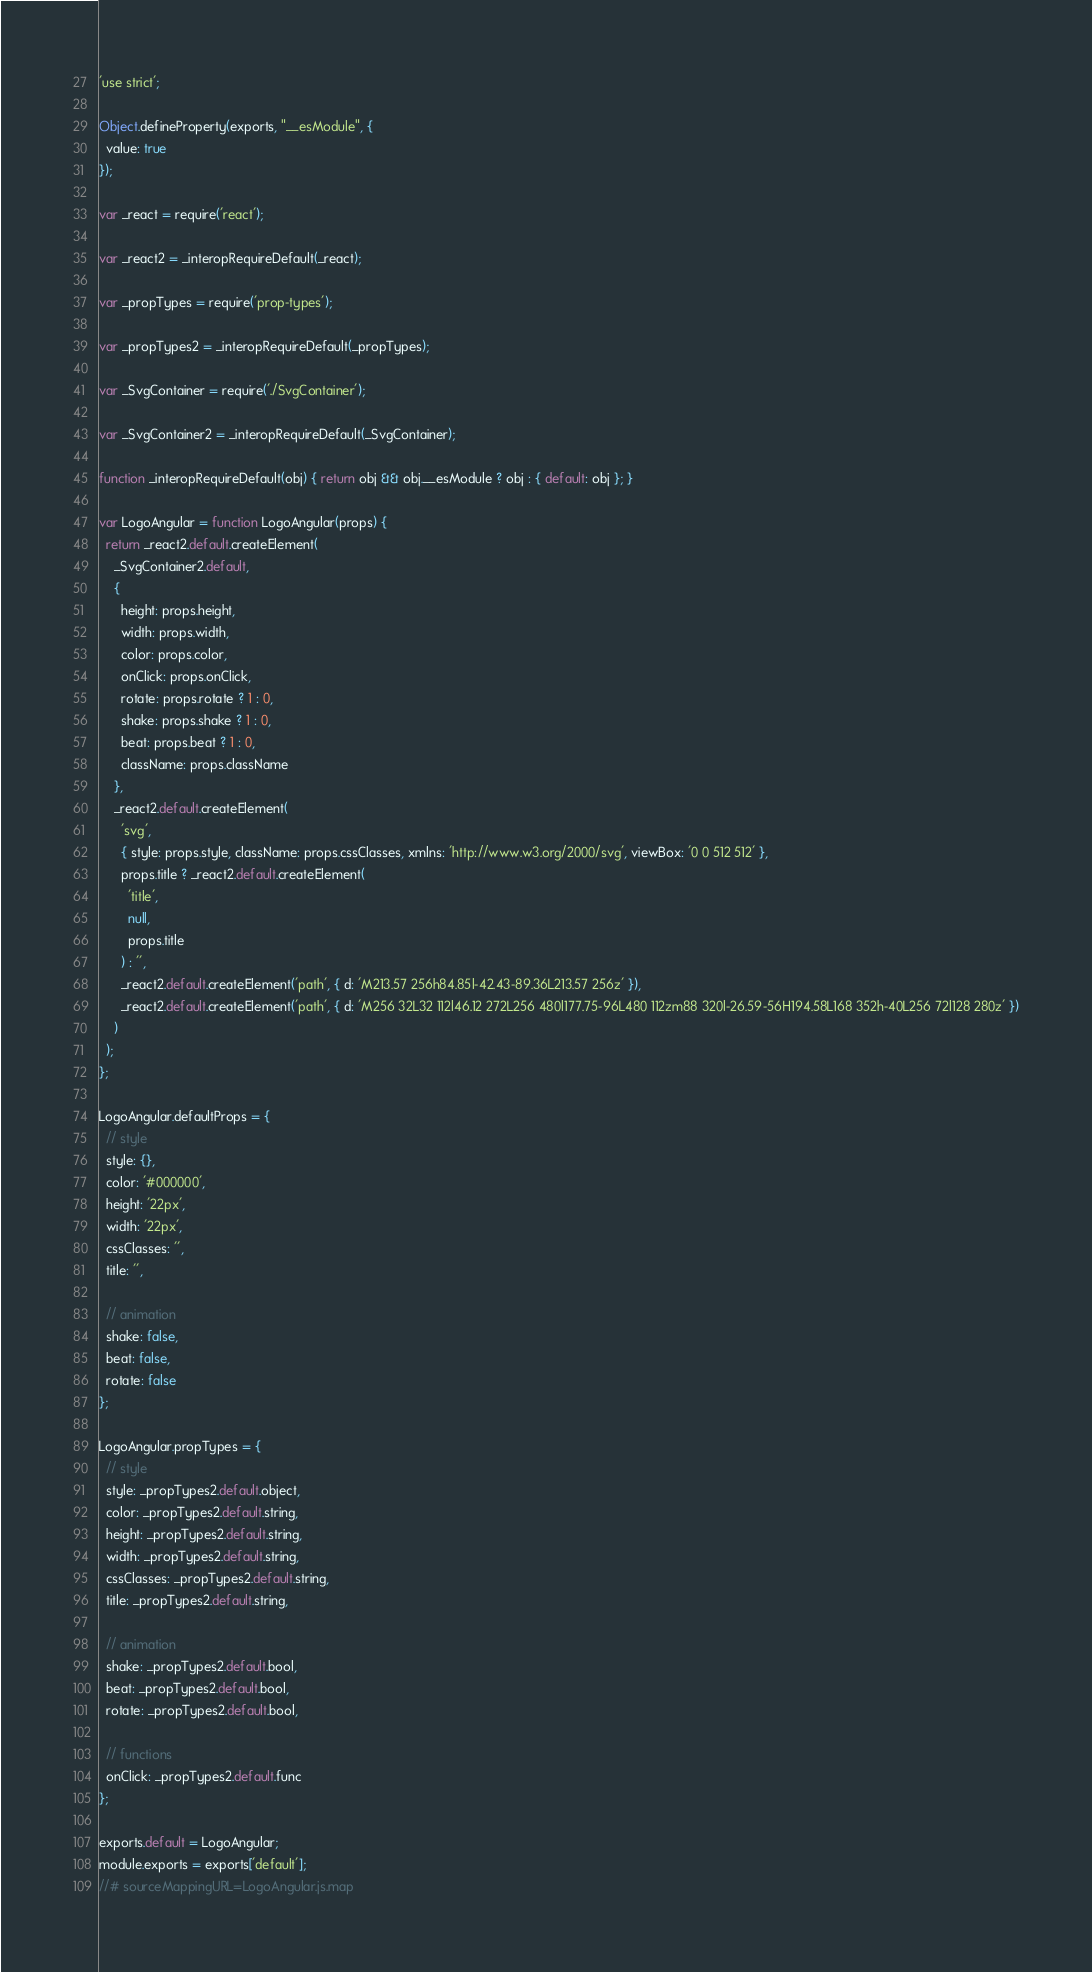<code> <loc_0><loc_0><loc_500><loc_500><_JavaScript_>'use strict';

Object.defineProperty(exports, "__esModule", {
  value: true
});

var _react = require('react');

var _react2 = _interopRequireDefault(_react);

var _propTypes = require('prop-types');

var _propTypes2 = _interopRequireDefault(_propTypes);

var _SvgContainer = require('./SvgContainer');

var _SvgContainer2 = _interopRequireDefault(_SvgContainer);

function _interopRequireDefault(obj) { return obj && obj.__esModule ? obj : { default: obj }; }

var LogoAngular = function LogoAngular(props) {
  return _react2.default.createElement(
    _SvgContainer2.default,
    {
      height: props.height,
      width: props.width,
      color: props.color,
      onClick: props.onClick,
      rotate: props.rotate ? 1 : 0,
      shake: props.shake ? 1 : 0,
      beat: props.beat ? 1 : 0,
      className: props.className
    },
    _react2.default.createElement(
      'svg',
      { style: props.style, className: props.cssClasses, xmlns: 'http://www.w3.org/2000/svg', viewBox: '0 0 512 512' },
      props.title ? _react2.default.createElement(
        'title',
        null,
        props.title
      ) : '',
      _react2.default.createElement('path', { d: 'M213.57 256h84.85l-42.43-89.36L213.57 256z' }),
      _react2.default.createElement('path', { d: 'M256 32L32 112l46.12 272L256 480l177.75-96L480 112zm88 320l-26.59-56H194.58L168 352h-40L256 72l128 280z' })
    )
  );
};

LogoAngular.defaultProps = {
  // style
  style: {},
  color: '#000000',
  height: '22px',
  width: '22px',
  cssClasses: '',
  title: '',

  // animation
  shake: false,
  beat: false,
  rotate: false
};

LogoAngular.propTypes = {
  // style
  style: _propTypes2.default.object,
  color: _propTypes2.default.string,
  height: _propTypes2.default.string,
  width: _propTypes2.default.string,
  cssClasses: _propTypes2.default.string,
  title: _propTypes2.default.string,

  // animation
  shake: _propTypes2.default.bool,
  beat: _propTypes2.default.bool,
  rotate: _propTypes2.default.bool,

  // functions
  onClick: _propTypes2.default.func
};

exports.default = LogoAngular;
module.exports = exports['default'];
//# sourceMappingURL=LogoAngular.js.map</code> 